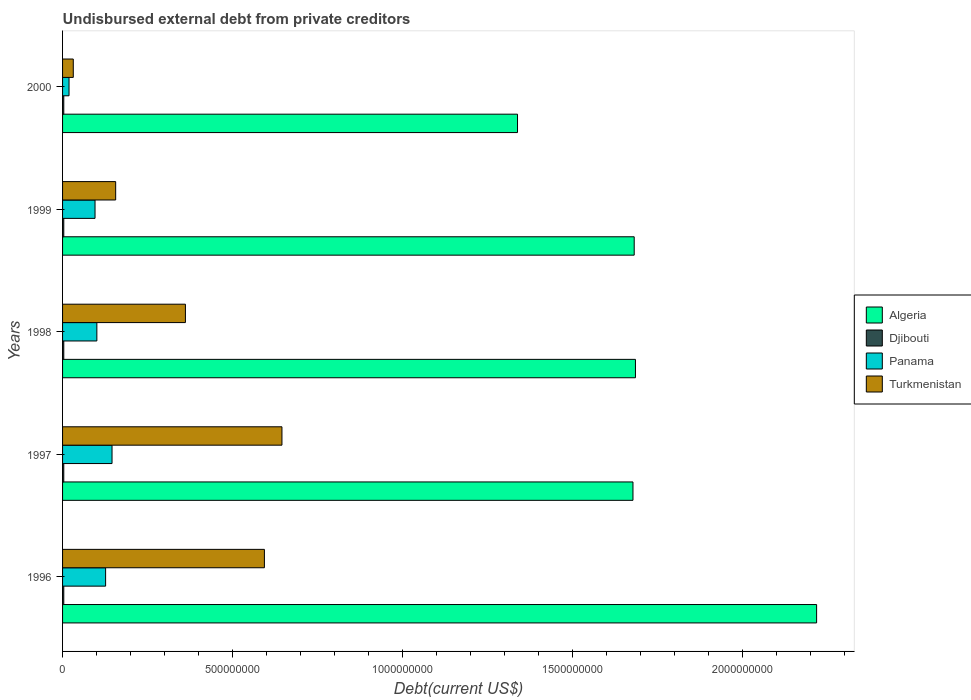How many different coloured bars are there?
Offer a terse response. 4. Are the number of bars per tick equal to the number of legend labels?
Offer a terse response. Yes. What is the label of the 3rd group of bars from the top?
Offer a very short reply. 1998. What is the total debt in Djibouti in 2000?
Offer a very short reply. 3.57e+06. Across all years, what is the maximum total debt in Turkmenistan?
Provide a succinct answer. 6.46e+08. Across all years, what is the minimum total debt in Turkmenistan?
Your response must be concise. 3.15e+07. In which year was the total debt in Panama maximum?
Your answer should be very brief. 1997. What is the total total debt in Algeria in the graph?
Your response must be concise. 8.60e+09. What is the difference between the total debt in Panama in 1996 and that in 1998?
Your answer should be very brief. 2.58e+07. What is the difference between the total debt in Djibouti in 1997 and the total debt in Panama in 1998?
Offer a very short reply. -9.73e+07. What is the average total debt in Djibouti per year?
Offer a very short reply. 3.57e+06. In the year 1996, what is the difference between the total debt in Panama and total debt in Djibouti?
Offer a terse response. 1.23e+08. What is the ratio of the total debt in Panama in 1997 to that in 2000?
Give a very brief answer. 7.64. Is the total debt in Algeria in 1996 less than that in 2000?
Provide a short and direct response. No. Is the difference between the total debt in Panama in 1997 and 2000 greater than the difference between the total debt in Djibouti in 1997 and 2000?
Your response must be concise. Yes. What is the difference between the highest and the second highest total debt in Panama?
Offer a very short reply. 1.89e+07. What is the difference between the highest and the lowest total debt in Panama?
Make the answer very short. 1.27e+08. In how many years, is the total debt in Djibouti greater than the average total debt in Djibouti taken over all years?
Ensure brevity in your answer.  0. What does the 1st bar from the top in 1999 represents?
Make the answer very short. Turkmenistan. What does the 4th bar from the bottom in 1998 represents?
Offer a terse response. Turkmenistan. Are all the bars in the graph horizontal?
Offer a terse response. Yes. How many years are there in the graph?
Your answer should be very brief. 5. What is the difference between two consecutive major ticks on the X-axis?
Ensure brevity in your answer.  5.00e+08. Are the values on the major ticks of X-axis written in scientific E-notation?
Keep it short and to the point. No. Where does the legend appear in the graph?
Your answer should be very brief. Center right. How many legend labels are there?
Your response must be concise. 4. What is the title of the graph?
Offer a very short reply. Undisbursed external debt from private creditors. What is the label or title of the X-axis?
Offer a terse response. Debt(current US$). What is the Debt(current US$) of Algeria in 1996?
Provide a succinct answer. 2.22e+09. What is the Debt(current US$) of Djibouti in 1996?
Offer a terse response. 3.57e+06. What is the Debt(current US$) of Panama in 1996?
Offer a very short reply. 1.27e+08. What is the Debt(current US$) in Turkmenistan in 1996?
Give a very brief answer. 5.94e+08. What is the Debt(current US$) of Algeria in 1997?
Give a very brief answer. 1.68e+09. What is the Debt(current US$) of Djibouti in 1997?
Your answer should be very brief. 3.57e+06. What is the Debt(current US$) of Panama in 1997?
Offer a terse response. 1.46e+08. What is the Debt(current US$) in Turkmenistan in 1997?
Your answer should be compact. 6.46e+08. What is the Debt(current US$) in Algeria in 1998?
Offer a terse response. 1.69e+09. What is the Debt(current US$) of Djibouti in 1998?
Give a very brief answer. 3.57e+06. What is the Debt(current US$) in Panama in 1998?
Offer a very short reply. 1.01e+08. What is the Debt(current US$) in Turkmenistan in 1998?
Your response must be concise. 3.62e+08. What is the Debt(current US$) of Algeria in 1999?
Provide a succinct answer. 1.68e+09. What is the Debt(current US$) in Djibouti in 1999?
Your answer should be very brief. 3.57e+06. What is the Debt(current US$) of Panama in 1999?
Offer a terse response. 9.55e+07. What is the Debt(current US$) in Turkmenistan in 1999?
Your answer should be compact. 1.56e+08. What is the Debt(current US$) of Algeria in 2000?
Your response must be concise. 1.34e+09. What is the Debt(current US$) in Djibouti in 2000?
Your answer should be very brief. 3.57e+06. What is the Debt(current US$) of Panama in 2000?
Give a very brief answer. 1.90e+07. What is the Debt(current US$) in Turkmenistan in 2000?
Offer a terse response. 3.15e+07. Across all years, what is the maximum Debt(current US$) of Algeria?
Your answer should be very brief. 2.22e+09. Across all years, what is the maximum Debt(current US$) in Djibouti?
Your response must be concise. 3.57e+06. Across all years, what is the maximum Debt(current US$) in Panama?
Your answer should be compact. 1.46e+08. Across all years, what is the maximum Debt(current US$) of Turkmenistan?
Your response must be concise. 6.46e+08. Across all years, what is the minimum Debt(current US$) in Algeria?
Your answer should be very brief. 1.34e+09. Across all years, what is the minimum Debt(current US$) in Djibouti?
Offer a terse response. 3.57e+06. Across all years, what is the minimum Debt(current US$) in Panama?
Ensure brevity in your answer.  1.90e+07. Across all years, what is the minimum Debt(current US$) in Turkmenistan?
Your answer should be very brief. 3.15e+07. What is the total Debt(current US$) of Algeria in the graph?
Your response must be concise. 8.60e+09. What is the total Debt(current US$) of Djibouti in the graph?
Make the answer very short. 1.78e+07. What is the total Debt(current US$) of Panama in the graph?
Offer a terse response. 4.88e+08. What is the total Debt(current US$) in Turkmenistan in the graph?
Offer a very short reply. 1.79e+09. What is the difference between the Debt(current US$) in Algeria in 1996 and that in 1997?
Offer a very short reply. 5.40e+08. What is the difference between the Debt(current US$) in Panama in 1996 and that in 1997?
Your answer should be very brief. -1.89e+07. What is the difference between the Debt(current US$) in Turkmenistan in 1996 and that in 1997?
Your answer should be very brief. -5.17e+07. What is the difference between the Debt(current US$) in Algeria in 1996 and that in 1998?
Offer a very short reply. 5.33e+08. What is the difference between the Debt(current US$) of Djibouti in 1996 and that in 1998?
Your response must be concise. 0. What is the difference between the Debt(current US$) in Panama in 1996 and that in 1998?
Offer a terse response. 2.58e+07. What is the difference between the Debt(current US$) in Turkmenistan in 1996 and that in 1998?
Offer a terse response. 2.32e+08. What is the difference between the Debt(current US$) in Algeria in 1996 and that in 1999?
Make the answer very short. 5.37e+08. What is the difference between the Debt(current US$) of Panama in 1996 and that in 1999?
Ensure brevity in your answer.  3.11e+07. What is the difference between the Debt(current US$) of Turkmenistan in 1996 and that in 1999?
Your answer should be compact. 4.38e+08. What is the difference between the Debt(current US$) in Algeria in 1996 and that in 2000?
Your answer should be very brief. 8.80e+08. What is the difference between the Debt(current US$) of Panama in 1996 and that in 2000?
Your answer should be compact. 1.08e+08. What is the difference between the Debt(current US$) of Turkmenistan in 1996 and that in 2000?
Your answer should be compact. 5.62e+08. What is the difference between the Debt(current US$) in Algeria in 1997 and that in 1998?
Offer a very short reply. -7.31e+06. What is the difference between the Debt(current US$) in Djibouti in 1997 and that in 1998?
Provide a short and direct response. 0. What is the difference between the Debt(current US$) in Panama in 1997 and that in 1998?
Offer a terse response. 4.47e+07. What is the difference between the Debt(current US$) in Turkmenistan in 1997 and that in 1998?
Offer a very short reply. 2.84e+08. What is the difference between the Debt(current US$) of Algeria in 1997 and that in 1999?
Provide a succinct answer. -3.65e+06. What is the difference between the Debt(current US$) of Djibouti in 1997 and that in 1999?
Make the answer very short. 0. What is the difference between the Debt(current US$) in Panama in 1997 and that in 1999?
Ensure brevity in your answer.  5.00e+07. What is the difference between the Debt(current US$) in Turkmenistan in 1997 and that in 1999?
Ensure brevity in your answer.  4.89e+08. What is the difference between the Debt(current US$) in Algeria in 1997 and that in 2000?
Your answer should be very brief. 3.40e+08. What is the difference between the Debt(current US$) of Panama in 1997 and that in 2000?
Provide a succinct answer. 1.27e+08. What is the difference between the Debt(current US$) in Turkmenistan in 1997 and that in 2000?
Keep it short and to the point. 6.14e+08. What is the difference between the Debt(current US$) of Algeria in 1998 and that in 1999?
Give a very brief answer. 3.66e+06. What is the difference between the Debt(current US$) of Panama in 1998 and that in 1999?
Ensure brevity in your answer.  5.37e+06. What is the difference between the Debt(current US$) of Turkmenistan in 1998 and that in 1999?
Make the answer very short. 2.05e+08. What is the difference between the Debt(current US$) of Algeria in 1998 and that in 2000?
Offer a terse response. 3.47e+08. What is the difference between the Debt(current US$) in Panama in 1998 and that in 2000?
Offer a very short reply. 8.19e+07. What is the difference between the Debt(current US$) of Turkmenistan in 1998 and that in 2000?
Your answer should be compact. 3.30e+08. What is the difference between the Debt(current US$) in Algeria in 1999 and that in 2000?
Offer a very short reply. 3.43e+08. What is the difference between the Debt(current US$) of Panama in 1999 and that in 2000?
Your response must be concise. 7.65e+07. What is the difference between the Debt(current US$) of Turkmenistan in 1999 and that in 2000?
Keep it short and to the point. 1.25e+08. What is the difference between the Debt(current US$) in Algeria in 1996 and the Debt(current US$) in Djibouti in 1997?
Make the answer very short. 2.22e+09. What is the difference between the Debt(current US$) in Algeria in 1996 and the Debt(current US$) in Panama in 1997?
Your response must be concise. 2.07e+09. What is the difference between the Debt(current US$) in Algeria in 1996 and the Debt(current US$) in Turkmenistan in 1997?
Ensure brevity in your answer.  1.57e+09. What is the difference between the Debt(current US$) of Djibouti in 1996 and the Debt(current US$) of Panama in 1997?
Offer a very short reply. -1.42e+08. What is the difference between the Debt(current US$) of Djibouti in 1996 and the Debt(current US$) of Turkmenistan in 1997?
Your response must be concise. -6.42e+08. What is the difference between the Debt(current US$) in Panama in 1996 and the Debt(current US$) in Turkmenistan in 1997?
Provide a succinct answer. -5.19e+08. What is the difference between the Debt(current US$) in Algeria in 1996 and the Debt(current US$) in Djibouti in 1998?
Ensure brevity in your answer.  2.22e+09. What is the difference between the Debt(current US$) in Algeria in 1996 and the Debt(current US$) in Panama in 1998?
Offer a terse response. 2.12e+09. What is the difference between the Debt(current US$) in Algeria in 1996 and the Debt(current US$) in Turkmenistan in 1998?
Provide a succinct answer. 1.86e+09. What is the difference between the Debt(current US$) in Djibouti in 1996 and the Debt(current US$) in Panama in 1998?
Provide a succinct answer. -9.73e+07. What is the difference between the Debt(current US$) in Djibouti in 1996 and the Debt(current US$) in Turkmenistan in 1998?
Provide a succinct answer. -3.58e+08. What is the difference between the Debt(current US$) of Panama in 1996 and the Debt(current US$) of Turkmenistan in 1998?
Offer a terse response. -2.35e+08. What is the difference between the Debt(current US$) in Algeria in 1996 and the Debt(current US$) in Djibouti in 1999?
Provide a succinct answer. 2.22e+09. What is the difference between the Debt(current US$) in Algeria in 1996 and the Debt(current US$) in Panama in 1999?
Offer a terse response. 2.12e+09. What is the difference between the Debt(current US$) in Algeria in 1996 and the Debt(current US$) in Turkmenistan in 1999?
Your answer should be very brief. 2.06e+09. What is the difference between the Debt(current US$) of Djibouti in 1996 and the Debt(current US$) of Panama in 1999?
Offer a terse response. -9.20e+07. What is the difference between the Debt(current US$) of Djibouti in 1996 and the Debt(current US$) of Turkmenistan in 1999?
Ensure brevity in your answer.  -1.53e+08. What is the difference between the Debt(current US$) in Panama in 1996 and the Debt(current US$) in Turkmenistan in 1999?
Ensure brevity in your answer.  -2.96e+07. What is the difference between the Debt(current US$) of Algeria in 1996 and the Debt(current US$) of Djibouti in 2000?
Offer a very short reply. 2.22e+09. What is the difference between the Debt(current US$) of Algeria in 1996 and the Debt(current US$) of Panama in 2000?
Give a very brief answer. 2.20e+09. What is the difference between the Debt(current US$) in Algeria in 1996 and the Debt(current US$) in Turkmenistan in 2000?
Offer a terse response. 2.19e+09. What is the difference between the Debt(current US$) of Djibouti in 1996 and the Debt(current US$) of Panama in 2000?
Your answer should be compact. -1.55e+07. What is the difference between the Debt(current US$) in Djibouti in 1996 and the Debt(current US$) in Turkmenistan in 2000?
Provide a succinct answer. -2.80e+07. What is the difference between the Debt(current US$) in Panama in 1996 and the Debt(current US$) in Turkmenistan in 2000?
Your answer should be compact. 9.51e+07. What is the difference between the Debt(current US$) of Algeria in 1997 and the Debt(current US$) of Djibouti in 1998?
Make the answer very short. 1.67e+09. What is the difference between the Debt(current US$) in Algeria in 1997 and the Debt(current US$) in Panama in 1998?
Your answer should be very brief. 1.58e+09. What is the difference between the Debt(current US$) in Algeria in 1997 and the Debt(current US$) in Turkmenistan in 1998?
Your response must be concise. 1.32e+09. What is the difference between the Debt(current US$) in Djibouti in 1997 and the Debt(current US$) in Panama in 1998?
Provide a short and direct response. -9.73e+07. What is the difference between the Debt(current US$) of Djibouti in 1997 and the Debt(current US$) of Turkmenistan in 1998?
Give a very brief answer. -3.58e+08. What is the difference between the Debt(current US$) of Panama in 1997 and the Debt(current US$) of Turkmenistan in 1998?
Offer a terse response. -2.16e+08. What is the difference between the Debt(current US$) of Algeria in 1997 and the Debt(current US$) of Djibouti in 1999?
Offer a terse response. 1.67e+09. What is the difference between the Debt(current US$) in Algeria in 1997 and the Debt(current US$) in Panama in 1999?
Offer a very short reply. 1.58e+09. What is the difference between the Debt(current US$) of Algeria in 1997 and the Debt(current US$) of Turkmenistan in 1999?
Your response must be concise. 1.52e+09. What is the difference between the Debt(current US$) of Djibouti in 1997 and the Debt(current US$) of Panama in 1999?
Offer a very short reply. -9.20e+07. What is the difference between the Debt(current US$) of Djibouti in 1997 and the Debt(current US$) of Turkmenistan in 1999?
Your answer should be compact. -1.53e+08. What is the difference between the Debt(current US$) of Panama in 1997 and the Debt(current US$) of Turkmenistan in 1999?
Give a very brief answer. -1.07e+07. What is the difference between the Debt(current US$) of Algeria in 1997 and the Debt(current US$) of Djibouti in 2000?
Your answer should be compact. 1.67e+09. What is the difference between the Debt(current US$) of Algeria in 1997 and the Debt(current US$) of Panama in 2000?
Ensure brevity in your answer.  1.66e+09. What is the difference between the Debt(current US$) in Algeria in 1997 and the Debt(current US$) in Turkmenistan in 2000?
Your answer should be very brief. 1.65e+09. What is the difference between the Debt(current US$) in Djibouti in 1997 and the Debt(current US$) in Panama in 2000?
Your answer should be very brief. -1.55e+07. What is the difference between the Debt(current US$) of Djibouti in 1997 and the Debt(current US$) of Turkmenistan in 2000?
Your response must be concise. -2.80e+07. What is the difference between the Debt(current US$) in Panama in 1997 and the Debt(current US$) in Turkmenistan in 2000?
Your answer should be compact. 1.14e+08. What is the difference between the Debt(current US$) in Algeria in 1998 and the Debt(current US$) in Djibouti in 1999?
Provide a succinct answer. 1.68e+09. What is the difference between the Debt(current US$) in Algeria in 1998 and the Debt(current US$) in Panama in 1999?
Provide a short and direct response. 1.59e+09. What is the difference between the Debt(current US$) of Algeria in 1998 and the Debt(current US$) of Turkmenistan in 1999?
Offer a very short reply. 1.53e+09. What is the difference between the Debt(current US$) of Djibouti in 1998 and the Debt(current US$) of Panama in 1999?
Provide a succinct answer. -9.20e+07. What is the difference between the Debt(current US$) of Djibouti in 1998 and the Debt(current US$) of Turkmenistan in 1999?
Make the answer very short. -1.53e+08. What is the difference between the Debt(current US$) in Panama in 1998 and the Debt(current US$) in Turkmenistan in 1999?
Offer a terse response. -5.54e+07. What is the difference between the Debt(current US$) in Algeria in 1998 and the Debt(current US$) in Djibouti in 2000?
Ensure brevity in your answer.  1.68e+09. What is the difference between the Debt(current US$) in Algeria in 1998 and the Debt(current US$) in Panama in 2000?
Ensure brevity in your answer.  1.67e+09. What is the difference between the Debt(current US$) in Algeria in 1998 and the Debt(current US$) in Turkmenistan in 2000?
Offer a very short reply. 1.65e+09. What is the difference between the Debt(current US$) of Djibouti in 1998 and the Debt(current US$) of Panama in 2000?
Give a very brief answer. -1.55e+07. What is the difference between the Debt(current US$) of Djibouti in 1998 and the Debt(current US$) of Turkmenistan in 2000?
Ensure brevity in your answer.  -2.80e+07. What is the difference between the Debt(current US$) in Panama in 1998 and the Debt(current US$) in Turkmenistan in 2000?
Keep it short and to the point. 6.94e+07. What is the difference between the Debt(current US$) of Algeria in 1999 and the Debt(current US$) of Djibouti in 2000?
Provide a short and direct response. 1.68e+09. What is the difference between the Debt(current US$) of Algeria in 1999 and the Debt(current US$) of Panama in 2000?
Offer a terse response. 1.66e+09. What is the difference between the Debt(current US$) of Algeria in 1999 and the Debt(current US$) of Turkmenistan in 2000?
Provide a short and direct response. 1.65e+09. What is the difference between the Debt(current US$) of Djibouti in 1999 and the Debt(current US$) of Panama in 2000?
Your response must be concise. -1.55e+07. What is the difference between the Debt(current US$) in Djibouti in 1999 and the Debt(current US$) in Turkmenistan in 2000?
Your answer should be very brief. -2.80e+07. What is the difference between the Debt(current US$) in Panama in 1999 and the Debt(current US$) in Turkmenistan in 2000?
Your answer should be compact. 6.40e+07. What is the average Debt(current US$) in Algeria per year?
Offer a very short reply. 1.72e+09. What is the average Debt(current US$) of Djibouti per year?
Keep it short and to the point. 3.57e+06. What is the average Debt(current US$) in Panama per year?
Provide a short and direct response. 9.76e+07. What is the average Debt(current US$) of Turkmenistan per year?
Make the answer very short. 3.58e+08. In the year 1996, what is the difference between the Debt(current US$) of Algeria and Debt(current US$) of Djibouti?
Make the answer very short. 2.22e+09. In the year 1996, what is the difference between the Debt(current US$) of Algeria and Debt(current US$) of Panama?
Provide a short and direct response. 2.09e+09. In the year 1996, what is the difference between the Debt(current US$) of Algeria and Debt(current US$) of Turkmenistan?
Offer a very short reply. 1.62e+09. In the year 1996, what is the difference between the Debt(current US$) of Djibouti and Debt(current US$) of Panama?
Offer a terse response. -1.23e+08. In the year 1996, what is the difference between the Debt(current US$) in Djibouti and Debt(current US$) in Turkmenistan?
Provide a short and direct response. -5.90e+08. In the year 1996, what is the difference between the Debt(current US$) in Panama and Debt(current US$) in Turkmenistan?
Provide a short and direct response. -4.67e+08. In the year 1997, what is the difference between the Debt(current US$) in Algeria and Debt(current US$) in Djibouti?
Give a very brief answer. 1.67e+09. In the year 1997, what is the difference between the Debt(current US$) in Algeria and Debt(current US$) in Panama?
Provide a short and direct response. 1.53e+09. In the year 1997, what is the difference between the Debt(current US$) of Algeria and Debt(current US$) of Turkmenistan?
Your response must be concise. 1.03e+09. In the year 1997, what is the difference between the Debt(current US$) of Djibouti and Debt(current US$) of Panama?
Provide a short and direct response. -1.42e+08. In the year 1997, what is the difference between the Debt(current US$) in Djibouti and Debt(current US$) in Turkmenistan?
Offer a very short reply. -6.42e+08. In the year 1997, what is the difference between the Debt(current US$) of Panama and Debt(current US$) of Turkmenistan?
Ensure brevity in your answer.  -5.00e+08. In the year 1998, what is the difference between the Debt(current US$) of Algeria and Debt(current US$) of Djibouti?
Provide a succinct answer. 1.68e+09. In the year 1998, what is the difference between the Debt(current US$) in Algeria and Debt(current US$) in Panama?
Your response must be concise. 1.58e+09. In the year 1998, what is the difference between the Debt(current US$) of Algeria and Debt(current US$) of Turkmenistan?
Offer a very short reply. 1.32e+09. In the year 1998, what is the difference between the Debt(current US$) in Djibouti and Debt(current US$) in Panama?
Offer a very short reply. -9.73e+07. In the year 1998, what is the difference between the Debt(current US$) of Djibouti and Debt(current US$) of Turkmenistan?
Provide a succinct answer. -3.58e+08. In the year 1998, what is the difference between the Debt(current US$) in Panama and Debt(current US$) in Turkmenistan?
Your response must be concise. -2.61e+08. In the year 1999, what is the difference between the Debt(current US$) in Algeria and Debt(current US$) in Djibouti?
Your answer should be compact. 1.68e+09. In the year 1999, what is the difference between the Debt(current US$) of Algeria and Debt(current US$) of Panama?
Your answer should be very brief. 1.59e+09. In the year 1999, what is the difference between the Debt(current US$) of Algeria and Debt(current US$) of Turkmenistan?
Make the answer very short. 1.53e+09. In the year 1999, what is the difference between the Debt(current US$) in Djibouti and Debt(current US$) in Panama?
Provide a short and direct response. -9.20e+07. In the year 1999, what is the difference between the Debt(current US$) of Djibouti and Debt(current US$) of Turkmenistan?
Offer a terse response. -1.53e+08. In the year 1999, what is the difference between the Debt(current US$) in Panama and Debt(current US$) in Turkmenistan?
Your answer should be very brief. -6.08e+07. In the year 2000, what is the difference between the Debt(current US$) in Algeria and Debt(current US$) in Djibouti?
Your answer should be compact. 1.34e+09. In the year 2000, what is the difference between the Debt(current US$) of Algeria and Debt(current US$) of Panama?
Provide a succinct answer. 1.32e+09. In the year 2000, what is the difference between the Debt(current US$) of Algeria and Debt(current US$) of Turkmenistan?
Your answer should be very brief. 1.31e+09. In the year 2000, what is the difference between the Debt(current US$) in Djibouti and Debt(current US$) in Panama?
Make the answer very short. -1.55e+07. In the year 2000, what is the difference between the Debt(current US$) of Djibouti and Debt(current US$) of Turkmenistan?
Offer a very short reply. -2.80e+07. In the year 2000, what is the difference between the Debt(current US$) in Panama and Debt(current US$) in Turkmenistan?
Ensure brevity in your answer.  -1.25e+07. What is the ratio of the Debt(current US$) of Algeria in 1996 to that in 1997?
Provide a short and direct response. 1.32. What is the ratio of the Debt(current US$) of Djibouti in 1996 to that in 1997?
Provide a succinct answer. 1. What is the ratio of the Debt(current US$) in Panama in 1996 to that in 1997?
Your answer should be compact. 0.87. What is the ratio of the Debt(current US$) in Algeria in 1996 to that in 1998?
Offer a very short reply. 1.32. What is the ratio of the Debt(current US$) of Panama in 1996 to that in 1998?
Offer a terse response. 1.26. What is the ratio of the Debt(current US$) in Turkmenistan in 1996 to that in 1998?
Offer a terse response. 1.64. What is the ratio of the Debt(current US$) in Algeria in 1996 to that in 1999?
Make the answer very short. 1.32. What is the ratio of the Debt(current US$) in Djibouti in 1996 to that in 1999?
Offer a very short reply. 1. What is the ratio of the Debt(current US$) of Panama in 1996 to that in 1999?
Provide a succinct answer. 1.33. What is the ratio of the Debt(current US$) of Turkmenistan in 1996 to that in 1999?
Offer a terse response. 3.8. What is the ratio of the Debt(current US$) in Algeria in 1996 to that in 2000?
Provide a short and direct response. 1.66. What is the ratio of the Debt(current US$) of Panama in 1996 to that in 2000?
Make the answer very short. 6.65. What is the ratio of the Debt(current US$) of Turkmenistan in 1996 to that in 2000?
Provide a short and direct response. 18.84. What is the ratio of the Debt(current US$) in Algeria in 1997 to that in 1998?
Your answer should be compact. 1. What is the ratio of the Debt(current US$) in Djibouti in 1997 to that in 1998?
Keep it short and to the point. 1. What is the ratio of the Debt(current US$) of Panama in 1997 to that in 1998?
Offer a very short reply. 1.44. What is the ratio of the Debt(current US$) in Turkmenistan in 1997 to that in 1998?
Provide a succinct answer. 1.79. What is the ratio of the Debt(current US$) in Panama in 1997 to that in 1999?
Offer a terse response. 1.52. What is the ratio of the Debt(current US$) in Turkmenistan in 1997 to that in 1999?
Give a very brief answer. 4.13. What is the ratio of the Debt(current US$) in Algeria in 1997 to that in 2000?
Your answer should be very brief. 1.25. What is the ratio of the Debt(current US$) in Djibouti in 1997 to that in 2000?
Provide a short and direct response. 1. What is the ratio of the Debt(current US$) in Panama in 1997 to that in 2000?
Your answer should be very brief. 7.64. What is the ratio of the Debt(current US$) in Turkmenistan in 1997 to that in 2000?
Provide a succinct answer. 20.47. What is the ratio of the Debt(current US$) of Algeria in 1998 to that in 1999?
Your answer should be compact. 1. What is the ratio of the Debt(current US$) of Djibouti in 1998 to that in 1999?
Keep it short and to the point. 1. What is the ratio of the Debt(current US$) in Panama in 1998 to that in 1999?
Give a very brief answer. 1.06. What is the ratio of the Debt(current US$) in Turkmenistan in 1998 to that in 1999?
Your response must be concise. 2.31. What is the ratio of the Debt(current US$) of Algeria in 1998 to that in 2000?
Ensure brevity in your answer.  1.26. What is the ratio of the Debt(current US$) of Panama in 1998 to that in 2000?
Ensure brevity in your answer.  5.3. What is the ratio of the Debt(current US$) in Turkmenistan in 1998 to that in 2000?
Your response must be concise. 11.47. What is the ratio of the Debt(current US$) of Algeria in 1999 to that in 2000?
Your answer should be very brief. 1.26. What is the ratio of the Debt(current US$) of Djibouti in 1999 to that in 2000?
Keep it short and to the point. 1. What is the ratio of the Debt(current US$) of Panama in 1999 to that in 2000?
Your answer should be compact. 5.02. What is the ratio of the Debt(current US$) of Turkmenistan in 1999 to that in 2000?
Your answer should be very brief. 4.96. What is the difference between the highest and the second highest Debt(current US$) of Algeria?
Make the answer very short. 5.33e+08. What is the difference between the highest and the second highest Debt(current US$) of Djibouti?
Offer a terse response. 0. What is the difference between the highest and the second highest Debt(current US$) in Panama?
Provide a succinct answer. 1.89e+07. What is the difference between the highest and the second highest Debt(current US$) in Turkmenistan?
Provide a short and direct response. 5.17e+07. What is the difference between the highest and the lowest Debt(current US$) of Algeria?
Your response must be concise. 8.80e+08. What is the difference between the highest and the lowest Debt(current US$) in Panama?
Offer a terse response. 1.27e+08. What is the difference between the highest and the lowest Debt(current US$) in Turkmenistan?
Make the answer very short. 6.14e+08. 